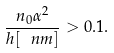<formula> <loc_0><loc_0><loc_500><loc_500>\frac { n _ { 0 } \alpha ^ { 2 } } { h [ \ n m ] } > 0 . 1 .</formula> 